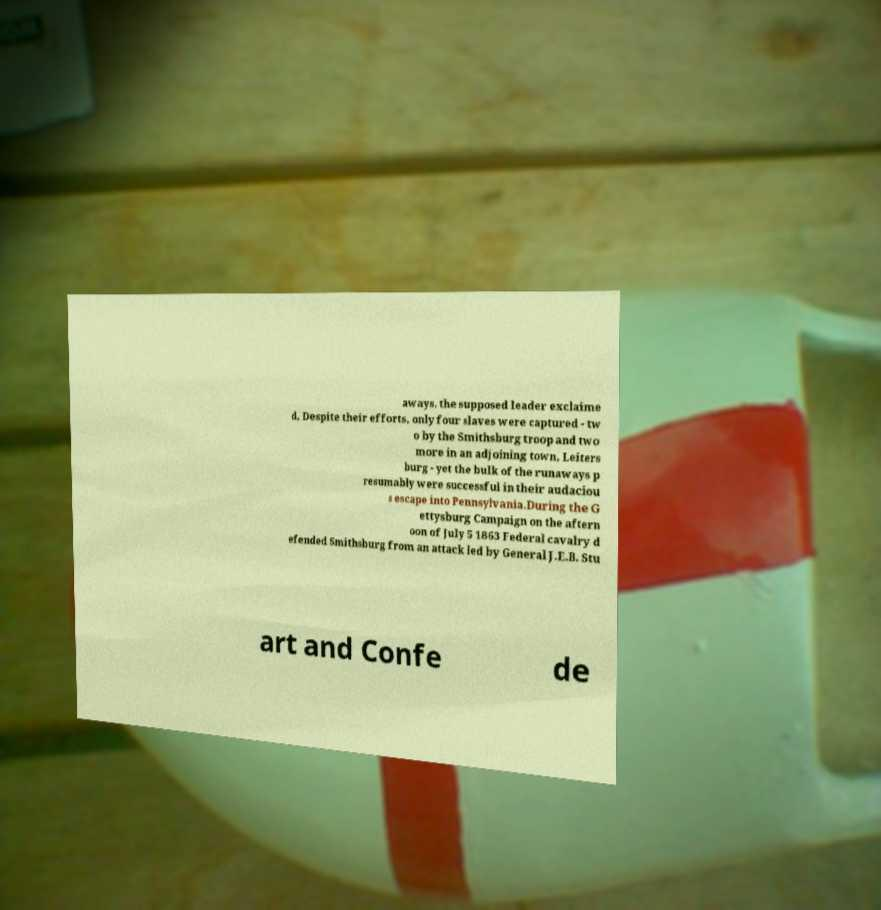Can you accurately transcribe the text from the provided image for me? aways, the supposed leader exclaime d, Despite their efforts, only four slaves were captured - tw o by the Smithsburg troop and two more in an adjoining town, Leiters burg - yet the bulk of the runaways p resumably were successful in their audaciou s escape into Pennsylvania.During the G ettysburg Campaign on the aftern oon of July 5 1863 Federal cavalry d efended Smithsburg from an attack led by General J.E.B. Stu art and Confe de 